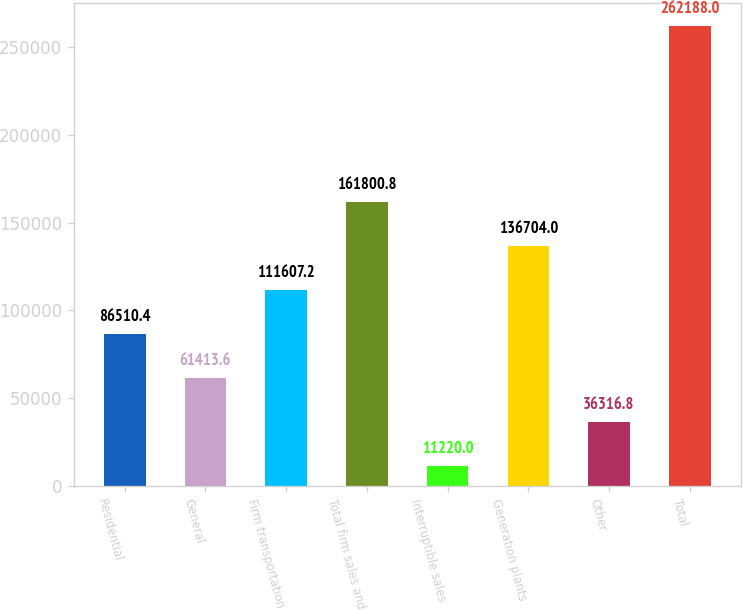Convert chart. <chart><loc_0><loc_0><loc_500><loc_500><bar_chart><fcel>Residential<fcel>General<fcel>Firm transportation<fcel>Total firm sales and<fcel>Interruptible sales<fcel>Generation plants<fcel>Other<fcel>Total<nl><fcel>86510.4<fcel>61413.6<fcel>111607<fcel>161801<fcel>11220<fcel>136704<fcel>36316.8<fcel>262188<nl></chart> 